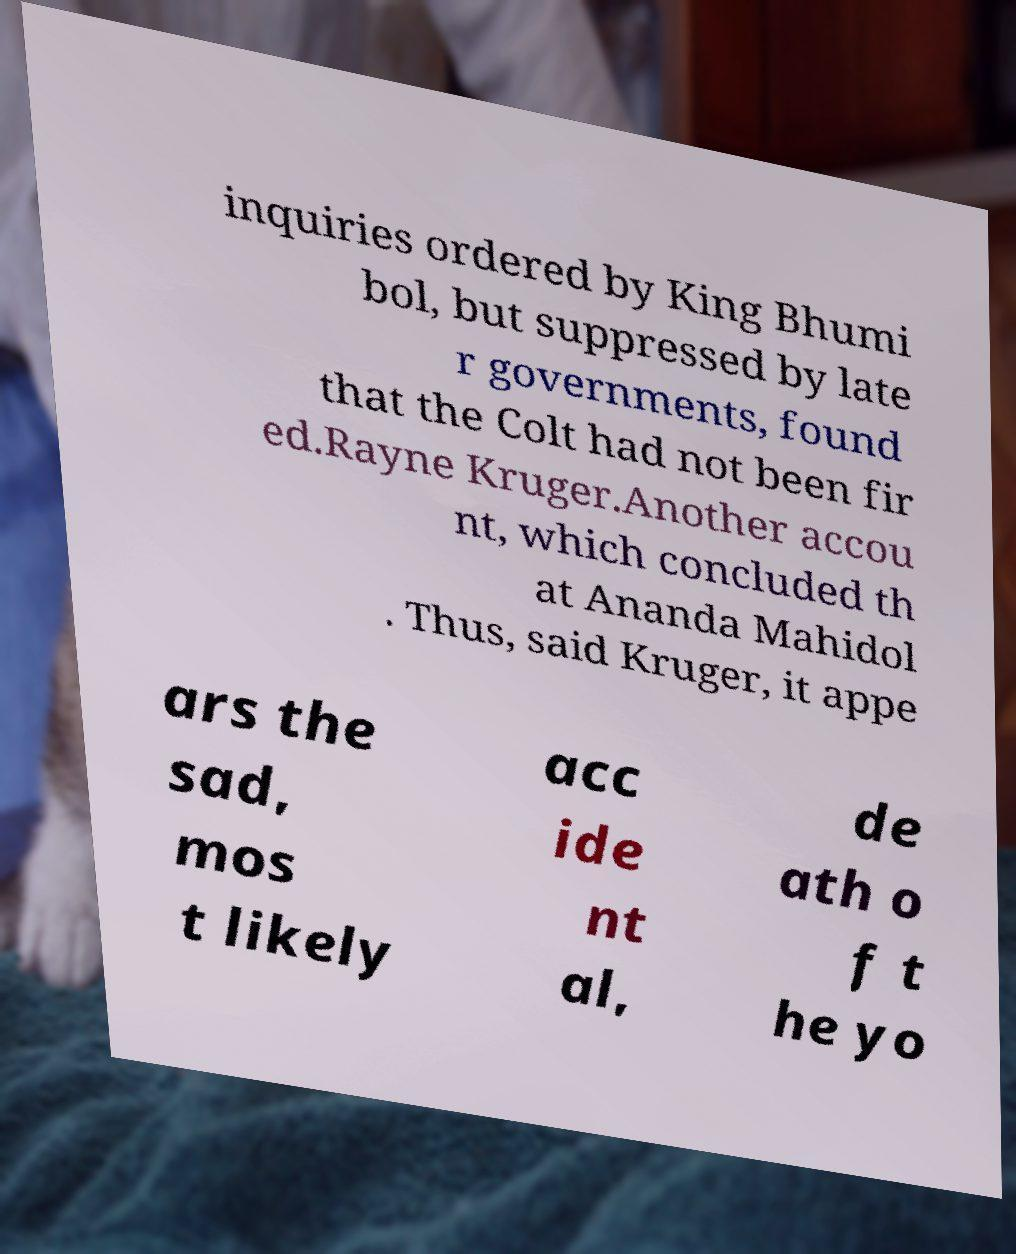For documentation purposes, I need the text within this image transcribed. Could you provide that? inquiries ordered by King Bhumi bol, but suppressed by late r governments, found that the Colt had not been fir ed.Rayne Kruger.Another accou nt, which concluded th at Ananda Mahidol . Thus, said Kruger, it appe ars the sad, mos t likely acc ide nt al, de ath o f t he yo 